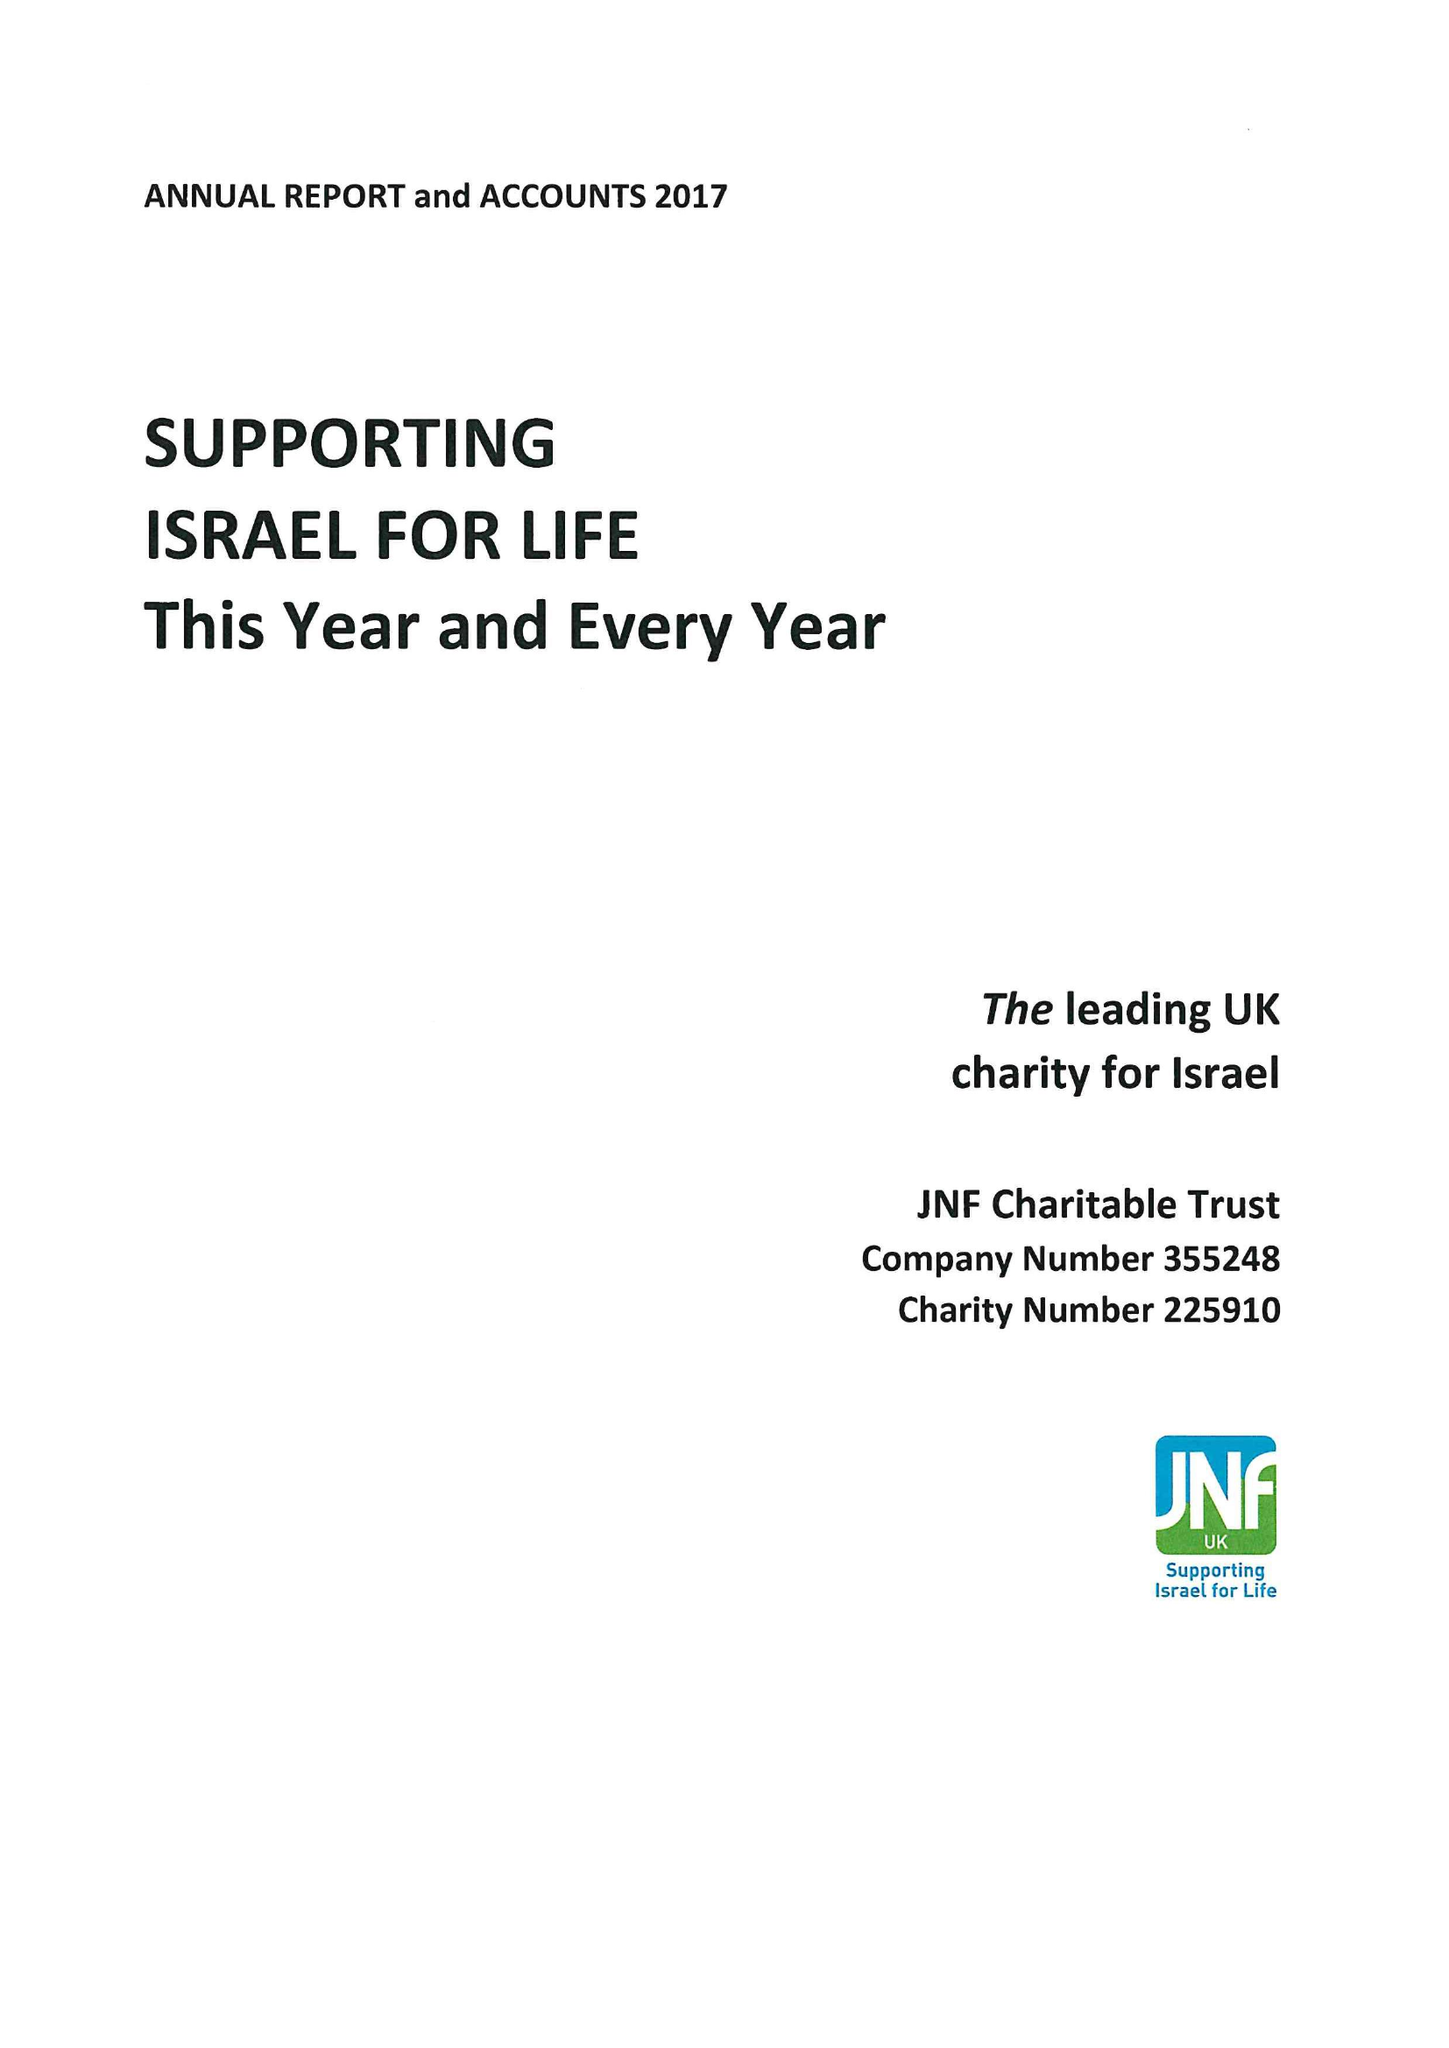What is the value for the report_date?
Answer the question using a single word or phrase. 2017-12-31 